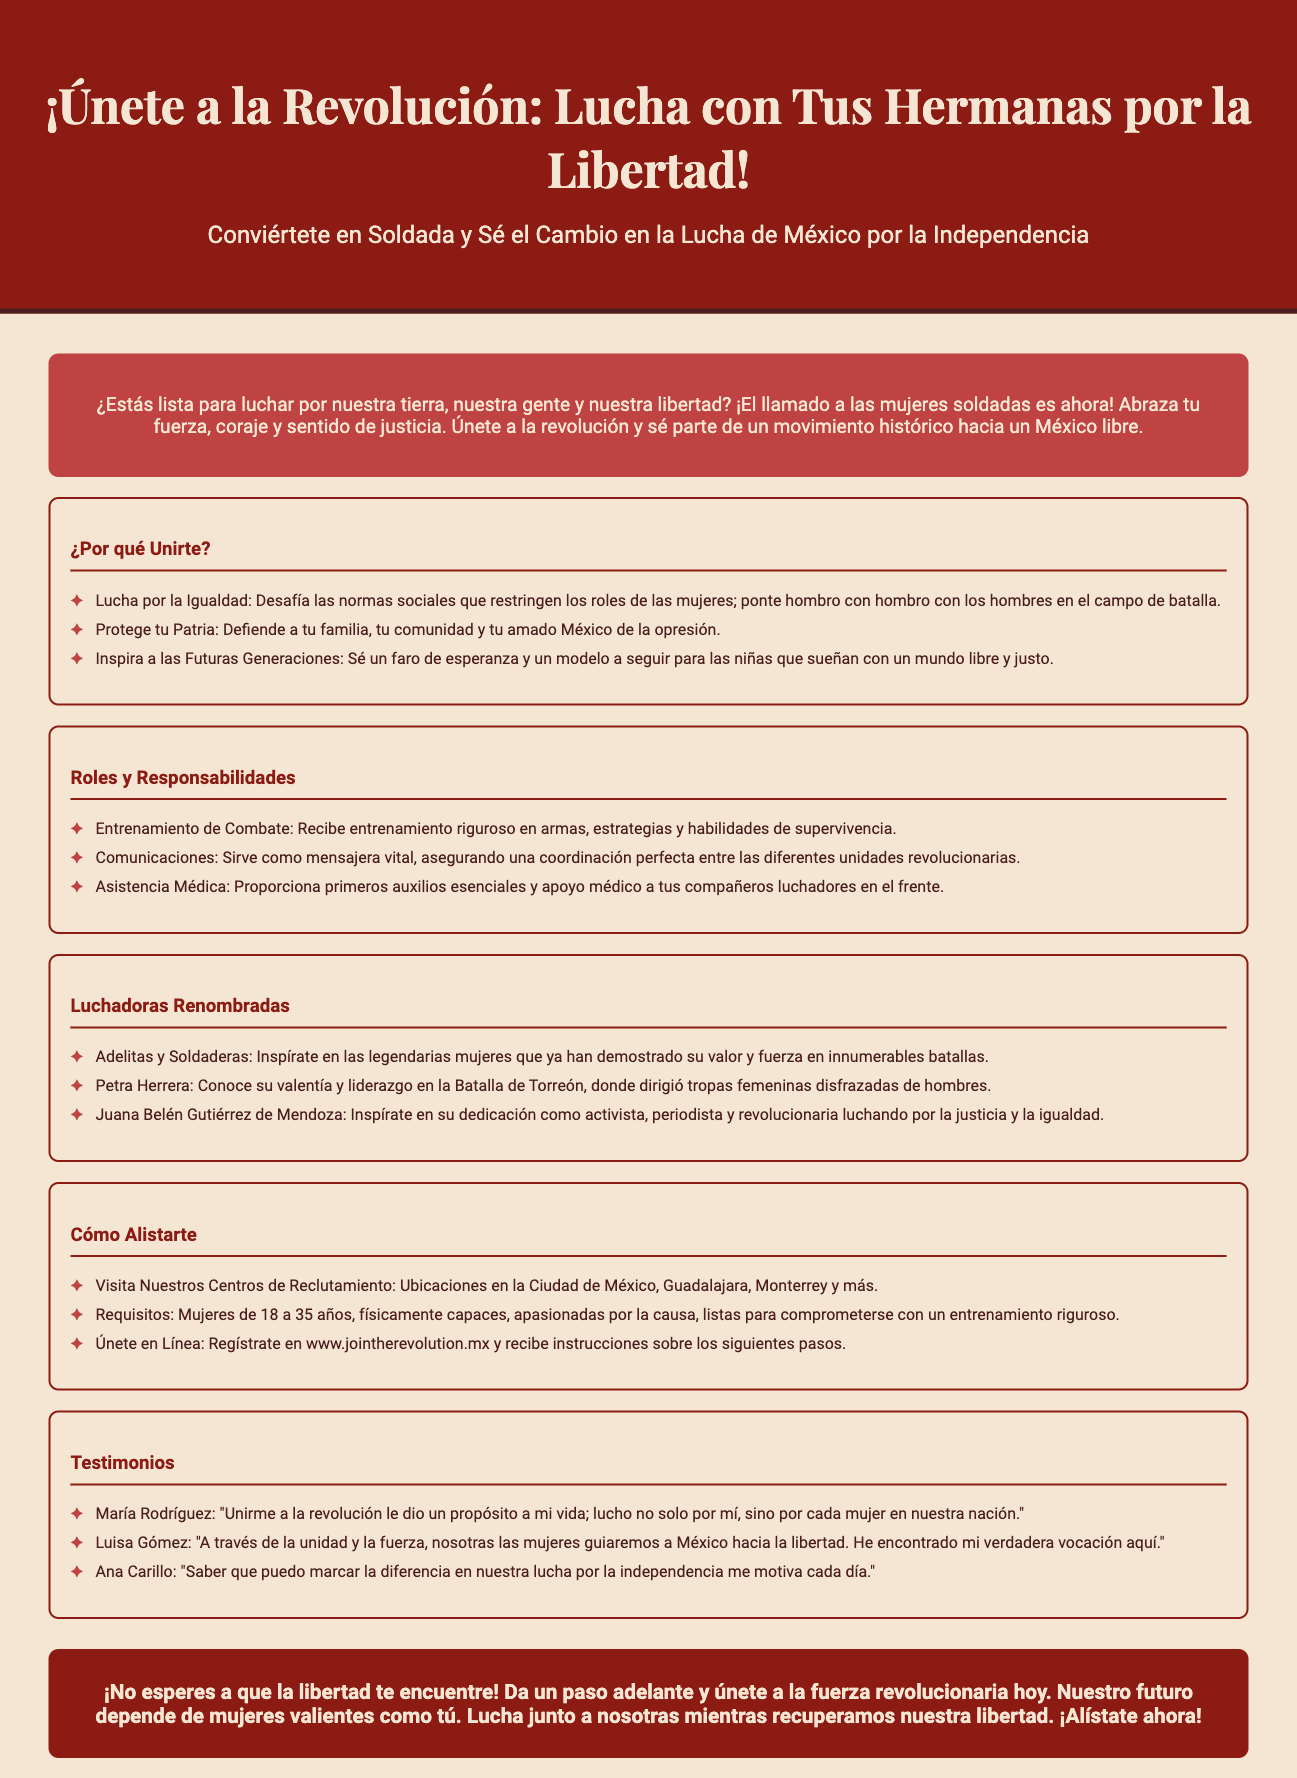¿Cuál es el título de la convocatoria? El título de la convocatoria es el encabezado que invita a las mujeres a unirse a la revolución.
Answer: ¡Únete a la Revolución: Lucha con Tus Hermanas por la Libertad! ¿Cuáles son los requisitos para alistarse? Los requisitos se detallan en la sección correspondiente sobre cómo alistarte en el documento.
Answer: Mujeres de 18 a 35 años, físicamente capaces, apasionadas por la causa ¿Cuál es un rol que las mujeres pueden desempeñar? Esta información se encuentra en la sección de roles y responsabilidades dentro del documento.
Answer: Entrenamiento de Combate ¿Dónde están ubicados los centros de reclutamiento? Están mencionados en la sección sobre cómo alistarte, que especifica varias ciudades.
Answer: Ciudad de México, Guadalajara, Monterrey ¿Quién es una luchadora renombrada mencionada en el documento? La sección de luchadoras renombradas detalla ejemplos de mujeres valientes en la revolución.
Answer: Petra Herrera ¿Qué tipo de testimonio se ofrece en el documento? Los testimonios están incluidos en la sección correspondiente, mostrando experiencias de mujeres que se unieron.
Answer: "Unirme a la revolución le dio un propósito a mi vida; lucho no solo por mí, sino por cada mujer en nuestra nación." ¿Por qué deberían las mujeres unirse a la revolución? La sección de razones para unirse explica motivaciones y el impacto de la participación femenina.
Answer: Lucha por la Igualdad ¿Cuál es la frase final que invita a la acción? La llamada a la acción se encuentra al final del documento, alentando a las mujeres a unirse.
Answer: ¡No esperes a que la libertad te encuentre! 